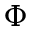Convert formula to latex. <formula><loc_0><loc_0><loc_500><loc_500>\Phi</formula> 